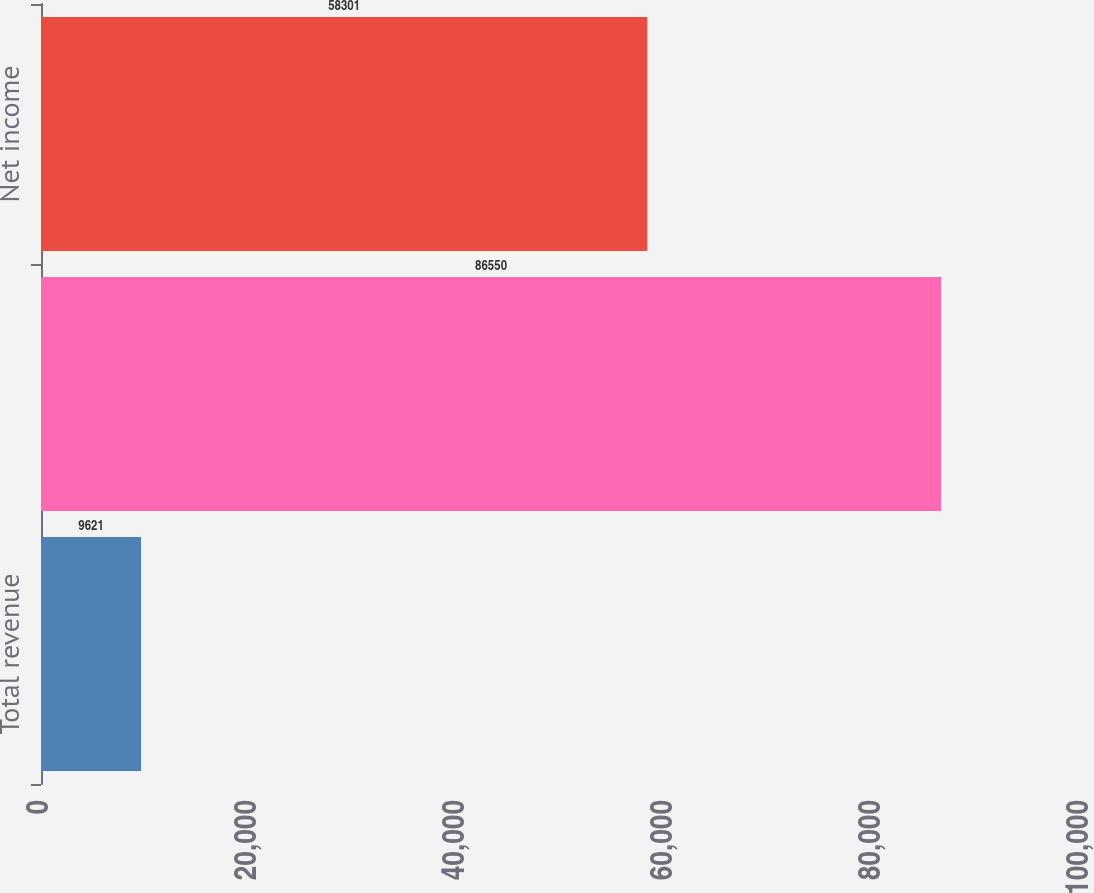Convert chart. <chart><loc_0><loc_0><loc_500><loc_500><bar_chart><fcel>Total revenue<fcel>Operating income<fcel>Net income<nl><fcel>9621<fcel>86550<fcel>58301<nl></chart> 